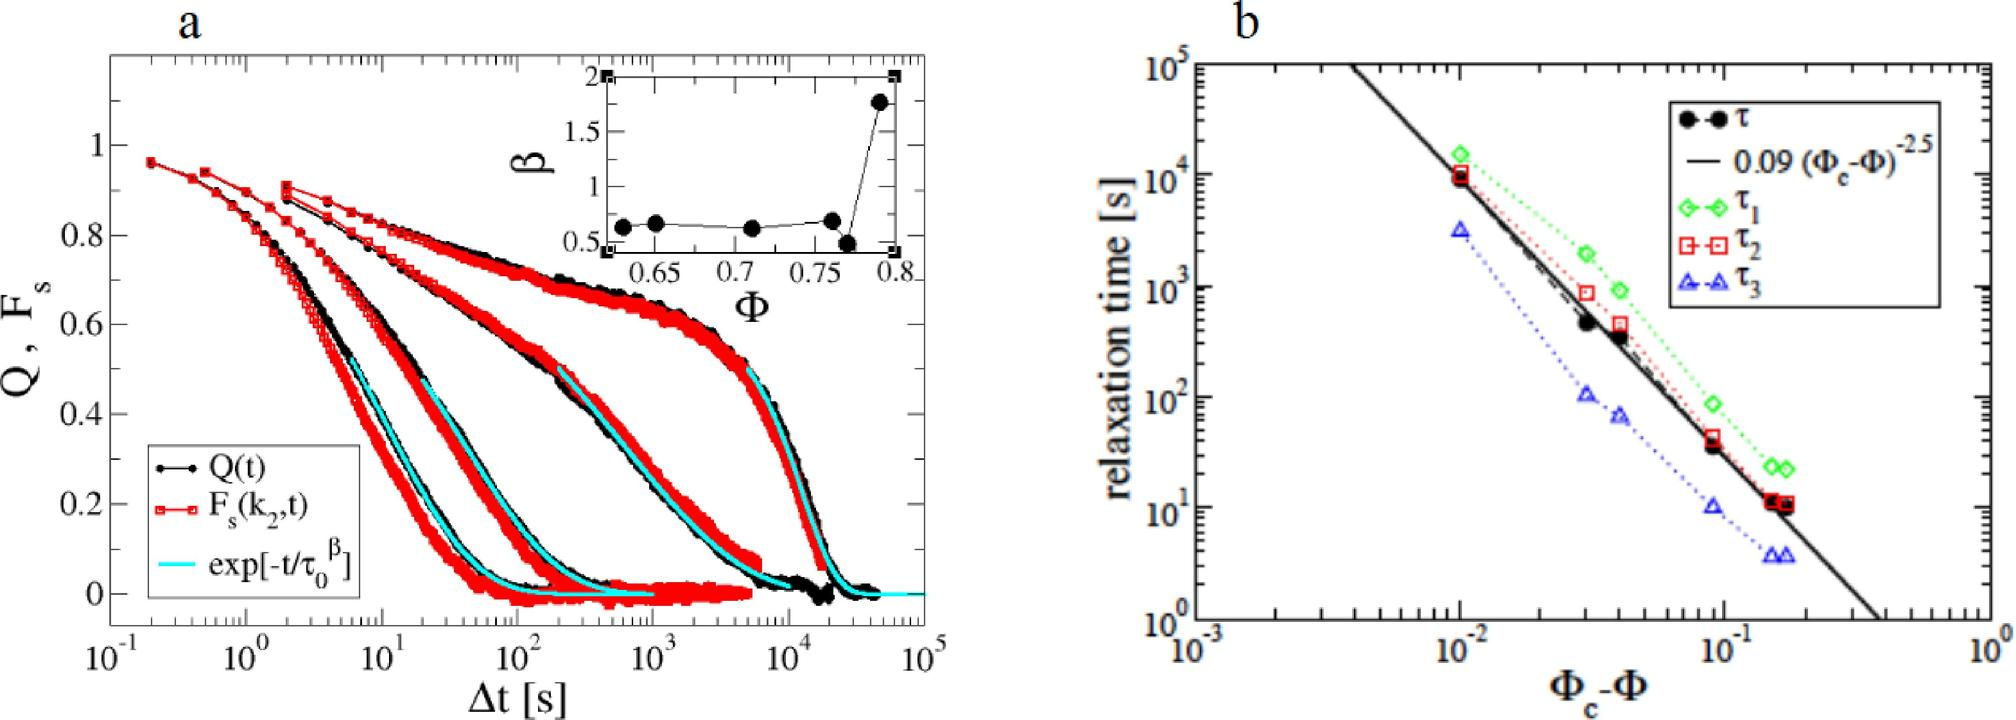In figure b, what does the dashed line represent? A. A fit of the relaxation time with respect to Φ - Φ_c B. The raw data of relaxation time for τ_1 C. The theoretical prediction for τ_2 D. A baseline for the relaxation times τ_1, τ_2, and τ_3 The dashed line in figure b is accompanied by the equation '0.09 (Φ - Φ_c)^-2.5', which suggests it is a fit representing how relaxation time scales with the difference Φ - Φ_c. Therefore, the correct answer is A. 